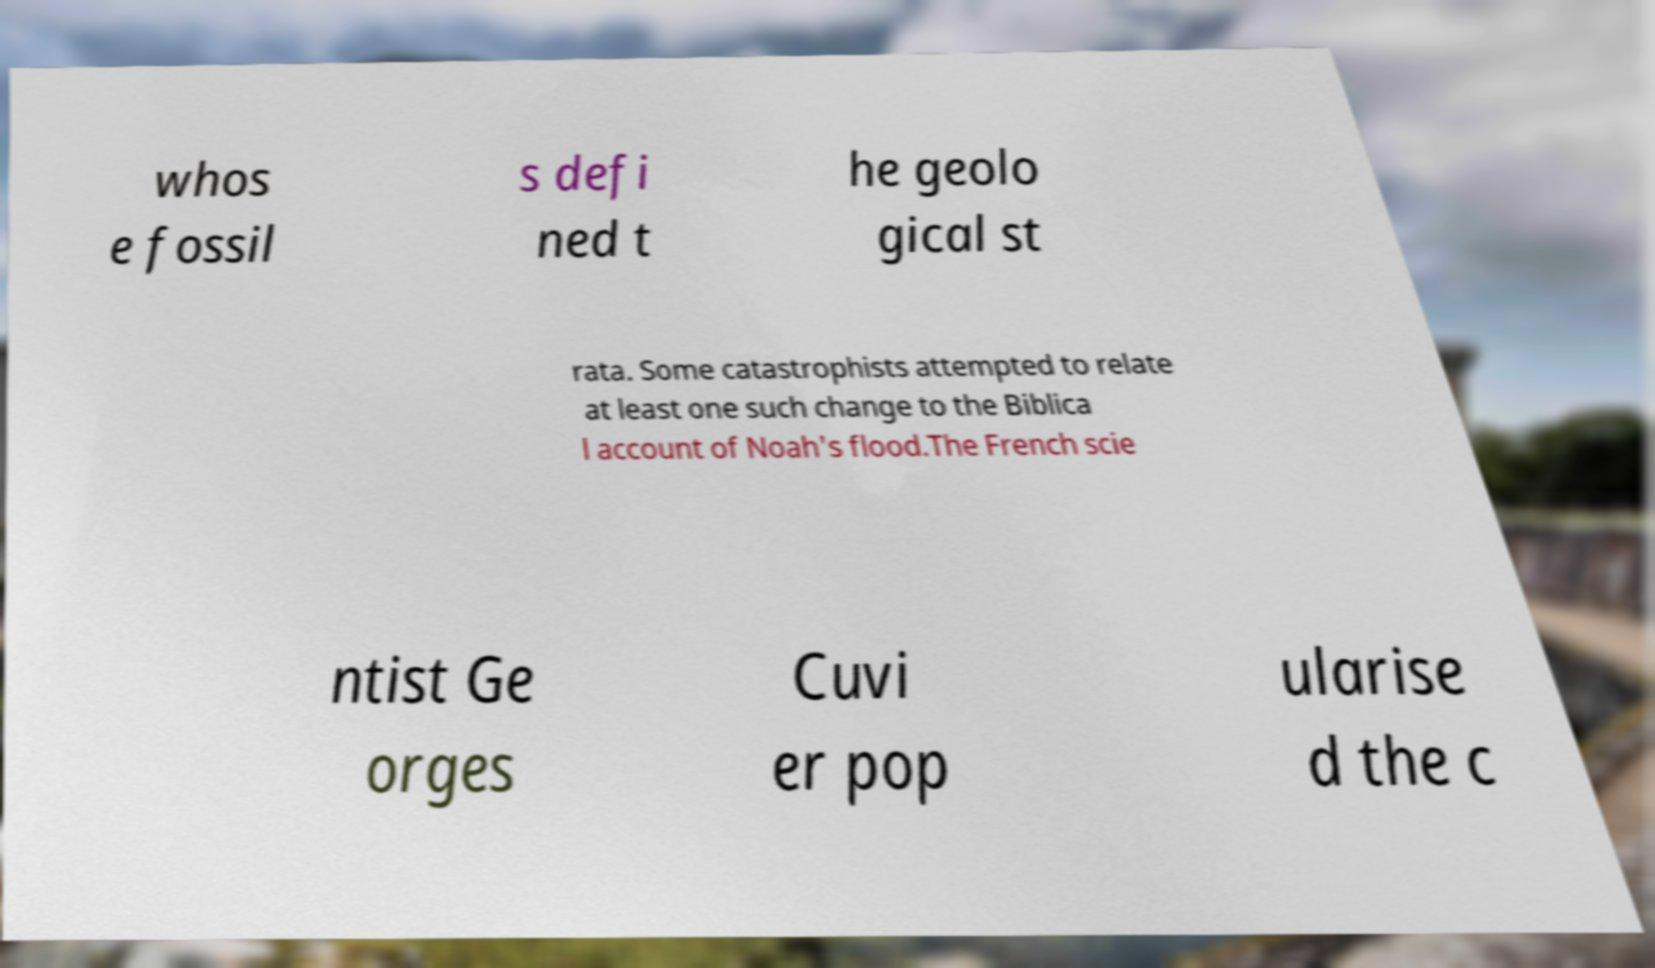What messages or text are displayed in this image? I need them in a readable, typed format. whos e fossil s defi ned t he geolo gical st rata. Some catastrophists attempted to relate at least one such change to the Biblica l account of Noah's flood.The French scie ntist Ge orges Cuvi er pop ularise d the c 